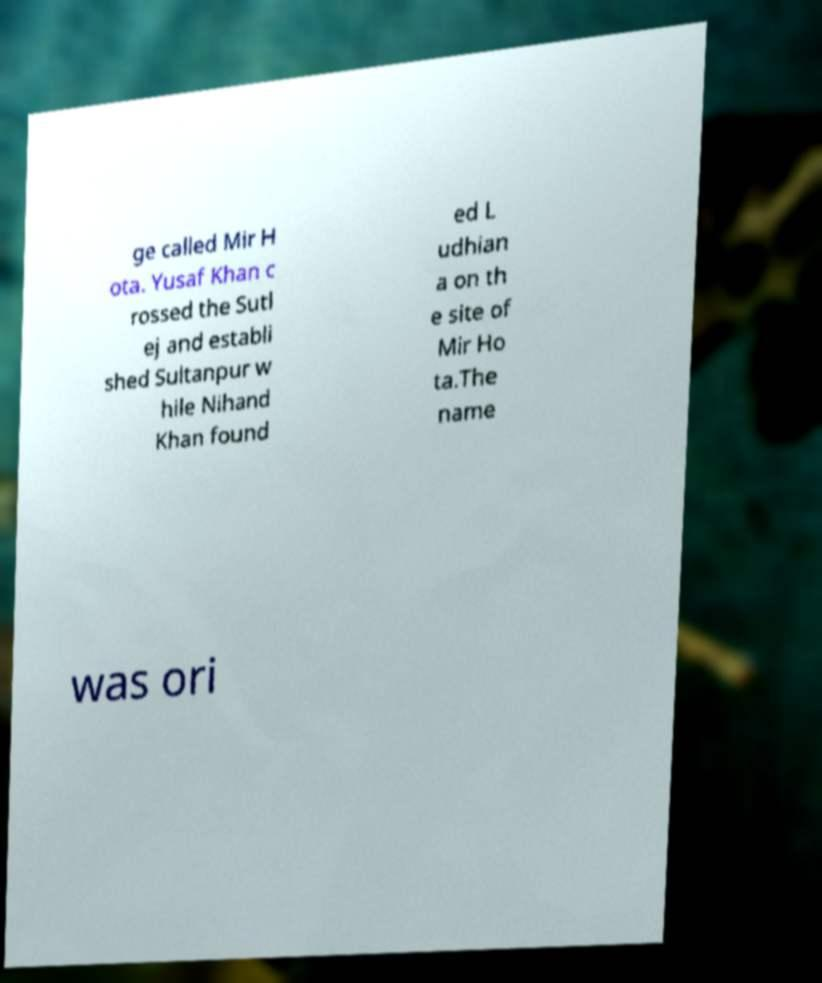For documentation purposes, I need the text within this image transcribed. Could you provide that? ge called Mir H ota. Yusaf Khan c rossed the Sutl ej and establi shed Sultanpur w hile Nihand Khan found ed L udhian a on th e site of Mir Ho ta.The name was ori 